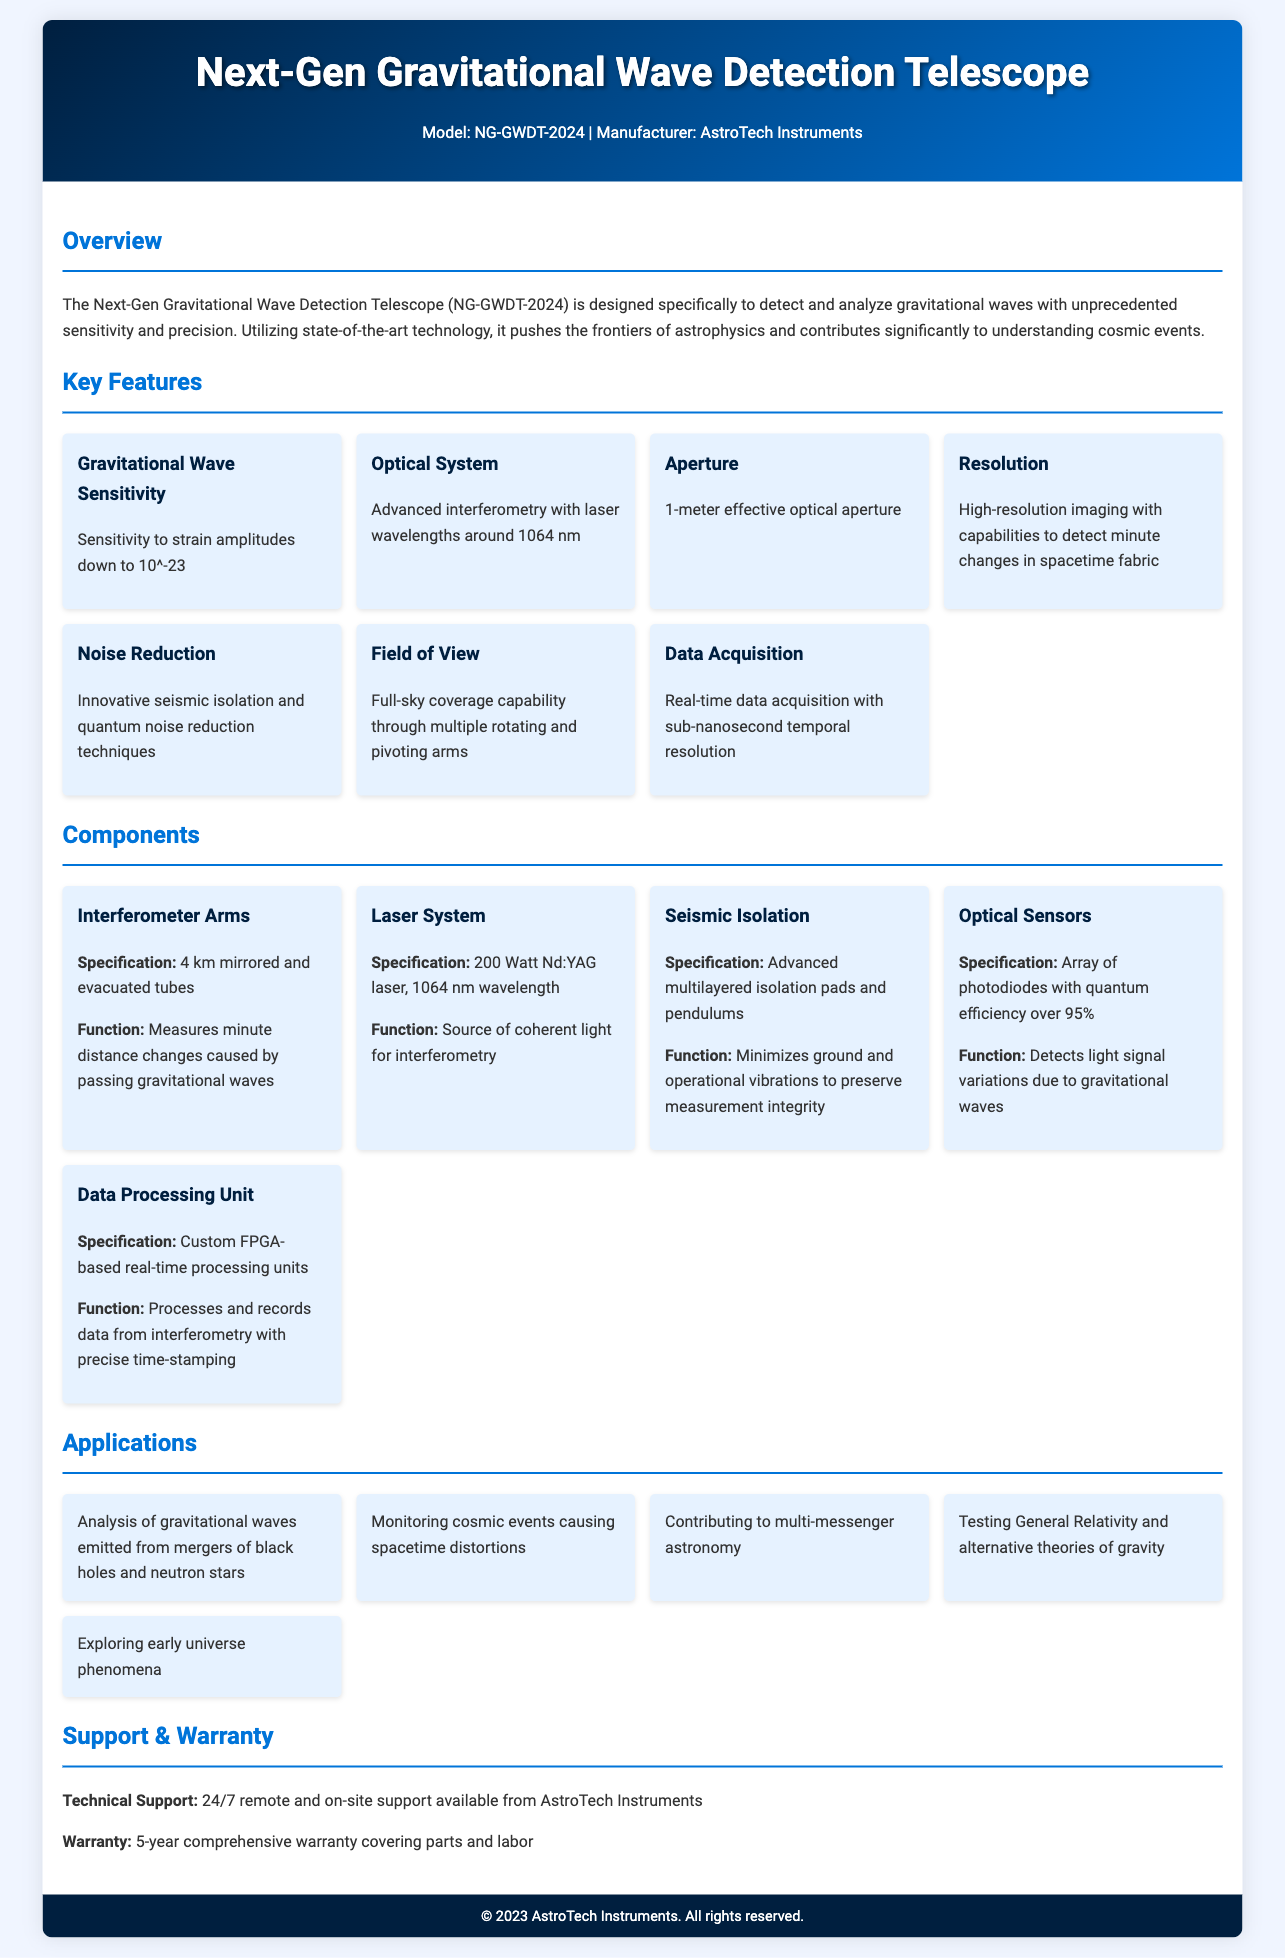What is the model of the telescope? The model of the telescope is mentioned in the header of the document.
Answer: NG-GWDT-2024 What is the effective optical aperture of the telescope? The effective optical aperture is specified under the Key Features section.
Answer: 1-meter What is the sensitivity to strain amplitudes? The sensitivity is provided as part of the key features about gravitational wave detection.
Answer: 10^-23 What type of laser is used in the telescope? The specification for the laser system is detailed in the Components section.
Answer: Nd:YAG laser How long are the interferometer arms? The length of the interferometer arms is stated in the components section.
Answer: 4 km What type of support is offered with this telescope? The support details can be found in the Support & Warranty section.
Answer: 24/7 remote and on-site support What is one application of the telescope? The applications are listed in their own section, providing various uses for the telescope.
Answer: Analysis of gravitational waves emitted from mergers of black holes and neutron stars What is the warranty period for the telescope? The warranty information is provided in the Support & Warranty section.
Answer: 5-year comprehensive warranty What technology is used for noise reduction? The noise reduction techniques are outlined under the key features of the document.
Answer: Seismic isolation and quantum noise reduction techniques 